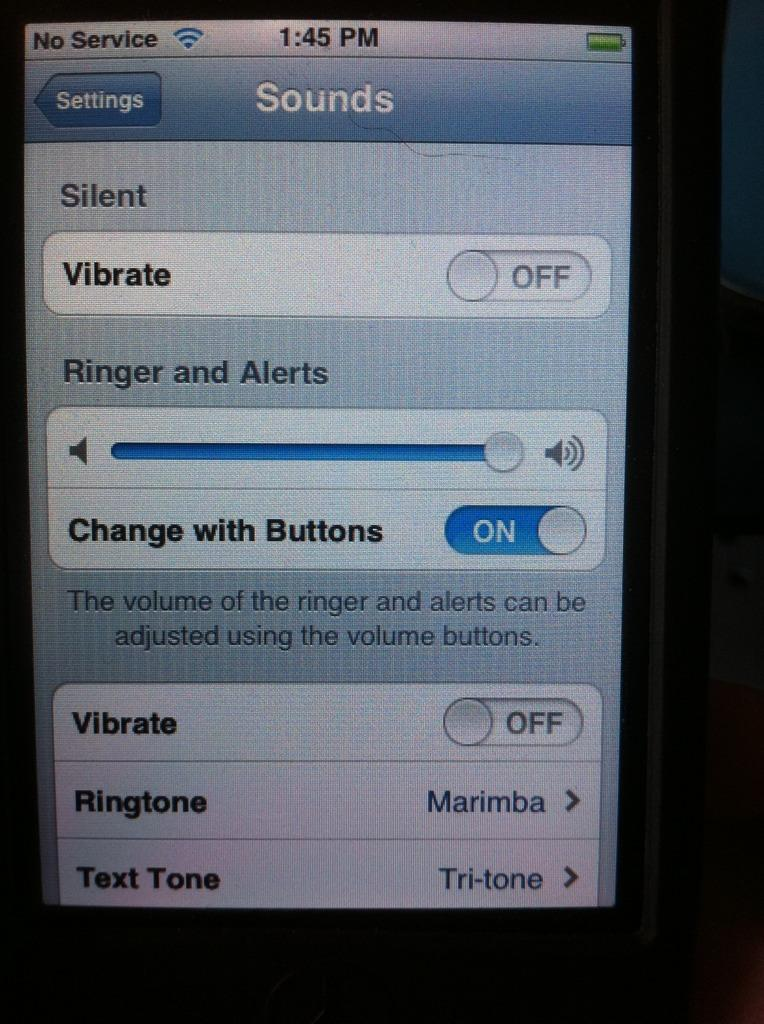<image>
Give a short and clear explanation of the subsequent image. A phone screen shows that vibrate is set to off. 